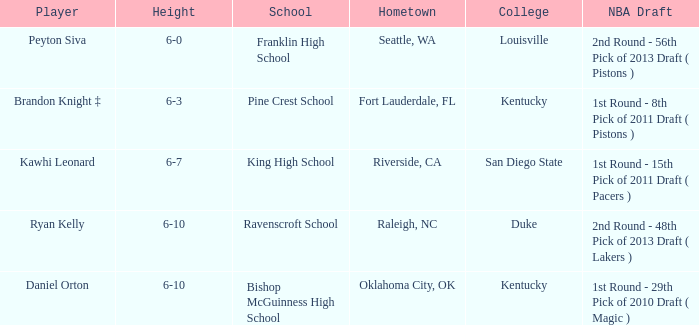Which school is in Riverside, CA? King High School. 